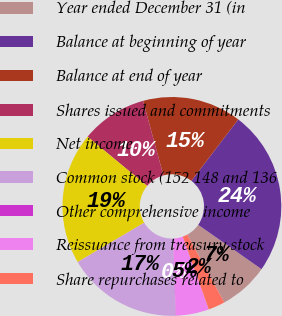Convert chart. <chart><loc_0><loc_0><loc_500><loc_500><pie_chart><fcel>Year ended December 31 (in<fcel>Balance at beginning of year<fcel>Balance at end of year<fcel>Shares issued and commitments<fcel>Net income<fcel>Common stock (152 148 and 136<fcel>Other comprehensive income<fcel>Reissuance from treasury stock<fcel>Share repurchases related to<nl><fcel>7.33%<fcel>24.35%<fcel>14.62%<fcel>9.76%<fcel>19.49%<fcel>17.05%<fcel>0.04%<fcel>4.9%<fcel>2.47%<nl></chart> 